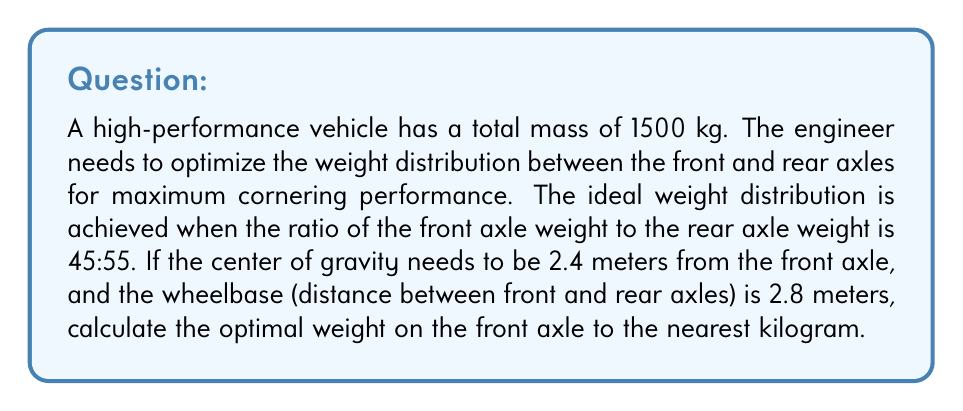Provide a solution to this math problem. To solve this problem, we'll use the concept of moments and the given ideal weight distribution ratio.

1. Let's define variables:
   $m_f$ = mass on front axle
   $m_r$ = mass on rear axle
   $M$ = total mass = 1500 kg
   $L$ = wheelbase = 2.8 m
   $d$ = distance of center of gravity from front axle = 2.4 m

2. We know that $m_f + m_r = M = 1500$ kg

3. The ideal weight distribution ratio is 45:55, so:
   $$\frac{m_f}{m_r} = \frac{45}{55} = \frac{9}{11}$$

4. Using the concept of moments, we can write:
   $$m_f \cdot L = M \cdot (L - d)$$

5. Substituting the known values:
   $$m_f \cdot 2.8 = 1500 \cdot (2.8 - 2.4)$$
   $$m_f \cdot 2.8 = 1500 \cdot 0.4$$
   $$m_f = \frac{1500 \cdot 0.4}{2.8} = 214.29 \text{ kg}$$

6. However, this doesn't satisfy our ideal weight distribution. Let's use the ratio to find the optimal weight:

   $$\frac{m_f}{1500 - m_f} = \frac{9}{11}$$

7. Solving this equation:
   $$11m_f = 9(1500 - m_f)$$
   $$11m_f = 13500 - 9m_f$$
   $$20m_f = 13500$$
   $$m_f = 675 \text{ kg}$$

8. Rounding to the nearest kilogram:
   $m_f = 675 \text{ kg}$
Answer: The optimal weight on the front axle is 675 kg. 